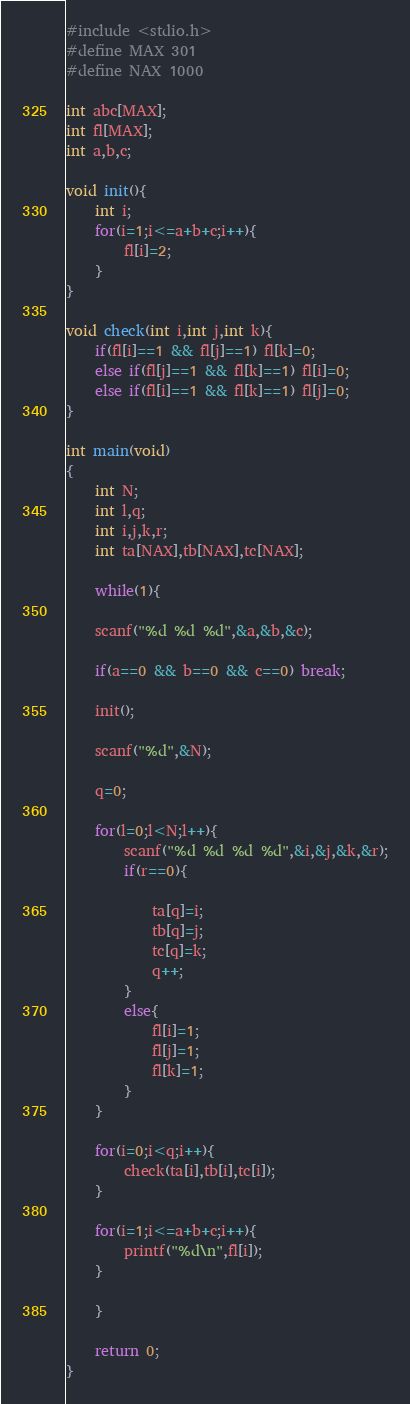<code> <loc_0><loc_0><loc_500><loc_500><_C_>#include <stdio.h>
#define MAX 301
#define NAX 1000

int abc[MAX];
int fl[MAX];
int a,b,c;

void init(){
	int i;
	for(i=1;i<=a+b+c;i++){
		fl[i]=2;
	}
}

void check(int i,int j,int k){
	if(fl[i]==1 && fl[j]==1) fl[k]=0;
	else if(fl[j]==1 && fl[k]==1) fl[i]=0;
	else if(fl[i]==1 && fl[k]==1) fl[j]=0;
}

int main(void)
{
	int N;
	int l,q;
	int i,j,k,r;
	int ta[NAX],tb[NAX],tc[NAX];
	
	while(1){
	
	scanf("%d %d %d",&a,&b,&c);
	
	if(a==0 && b==0 && c==0) break;
	
	init();
	
	scanf("%d",&N);
	
	q=0;
	
	for(l=0;l<N;l++){
		scanf("%d %d %d %d",&i,&j,&k,&r);
		if(r==0){
			
			ta[q]=i;
			tb[q]=j;
			tc[q]=k;
			q++;
		}
		else{
			fl[i]=1;
			fl[j]=1;
			fl[k]=1;
		}
	}
	
	for(i=0;i<q;i++){
		check(ta[i],tb[i],tc[i]);
	}
	
	for(i=1;i<=a+b+c;i++){
		printf("%d\n",fl[i]);
	}
	
	}
	
	return 0;
}</code> 